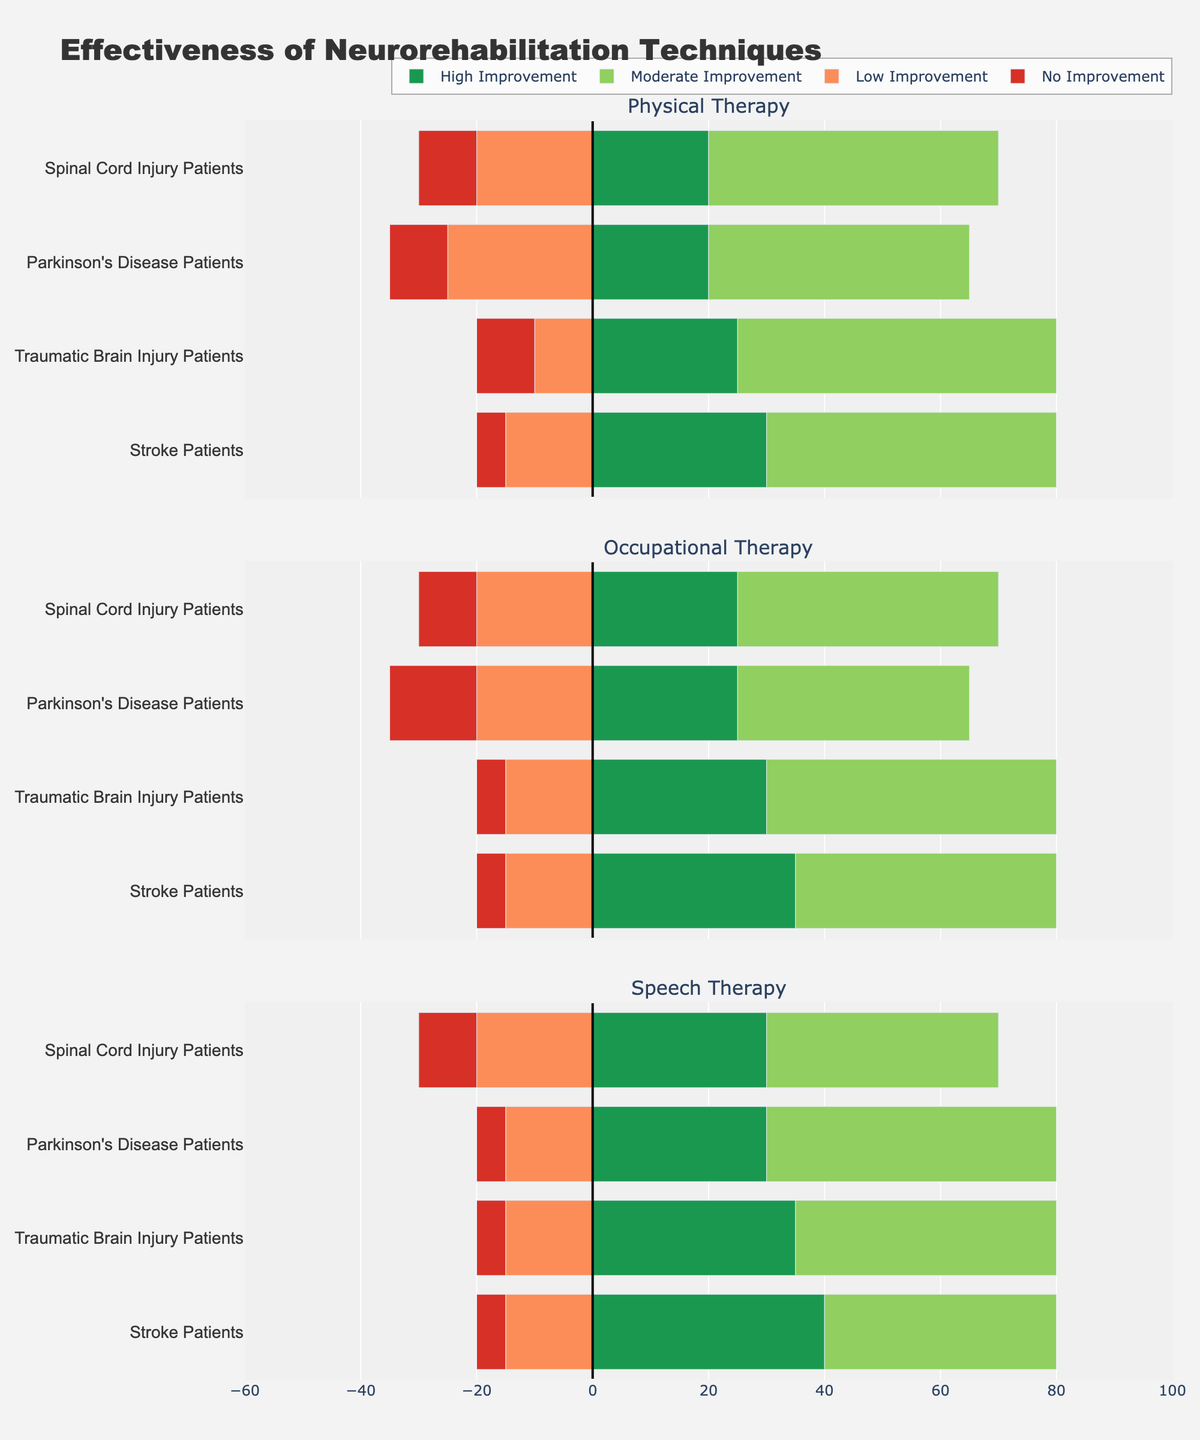How does the percentage of high improvement in Physical Therapy compare between Stroke Patients and Traumatic Brain Injury Patients? The plot shows Physical Therapy's percentage of high improvement as 30% for Stroke Patients and 25% for Traumatic Brain Injury Patients. By comparing these percentages, we conclude that Stroke Patients have a higher percentage of high improvement.
Answer: Stroke Patients have a higher percentage of high improvement Which technique shows the highest percentage of high improvement for Parkinson's Disease Patients? By evaluating the bars, Speech Therapy shows a 30% high improvement, higher than both Physical Therapy and Occupational Therapy, each showing 20% and 25% respectively.
Answer: Speech Therapy For Stroke Patients, how does the total percentage of any type of improvement (High, Moderate, and Low combined) compare across Physical Therapy and Occupational Therapy? Adding the percentages for Stroke Patients in Physical Therapy (30% + 50% + 15% = 95%) and Occupational Therapy (35% + 45% + 15% = 95%), we see they are equal.
Answer: They are equal Which patient group has the highest no improvement percentage under Speech Therapy? Speech Therapy bars show no improvement percentages as: Stroke Patients (5%), Traumatic Brain Injury Patients (5%), Parkinson's Disease Patients (5%), and Spinal Cord Injury Patients (10%). Comparing these, Spinal Cord Injury Patients have the highest no improvement percentage.
Answer: Spinal Cord Injury Patients Which technique has the highest total percentage of moderate improvement across all patient groups? Summing the moderate improvement percentages: 
- Physical Therapy: 50% + 55% + 45% + 50% = 200%
- Occupational Therapy: 45% + 50% + 40% + 45% = 180%
- Speech Therapy: 40% + 45% + 50% + 40% = 175%
We find that Physical Therapy has the highest total percentage of moderate improvement.
Answer: Physical Therapy For Spinal Cord Injury Patients, which technique shows the highest percentage of any improvement (High, Moderate, and Low combined)? Summing the percentages for each technique:
- Physical Therapy: 20% + 50% + 20% = 90%
- Occupational Therapy: 25% + 45% + 20% = 90%
- Speech Therapy: 30% + 40% + 20% = 90%
All three techniques show equal highest percentages for Spinal Cord Injury Patients.
Answer: All techniques are equal 